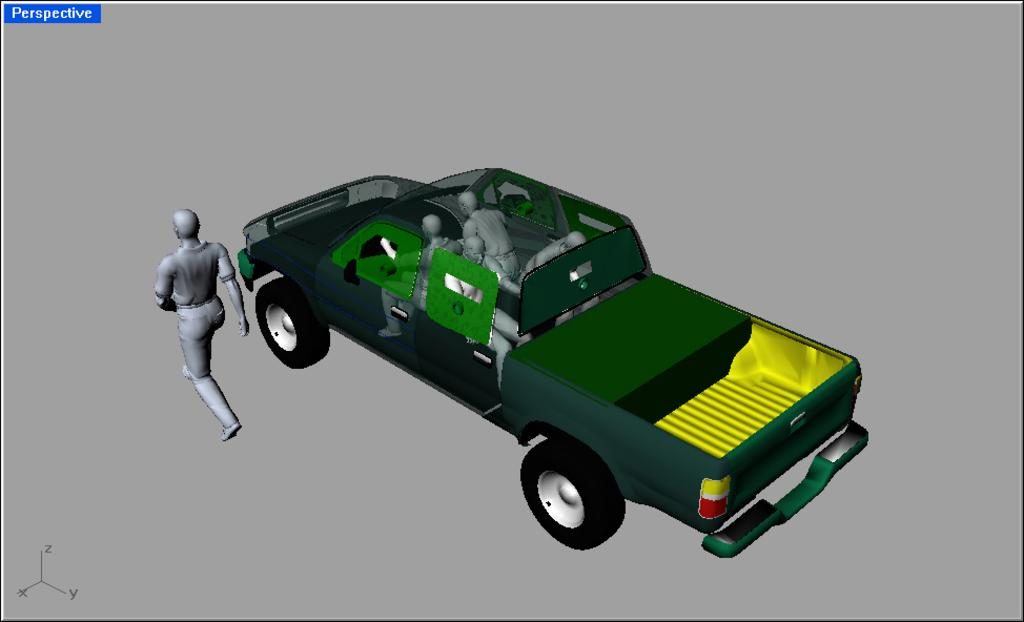What is the main subject of the image? The main subject of the image is a car. Are there any other elements present in the image besides the car? Yes, there are people in the image. What type of stretch is the car performing in the image? The car is not performing any stretch in the image; it is a stationary object. What type of frame is used to capture the image? The type of frame used to capture the image is not visible or mentioned in the image itself. 